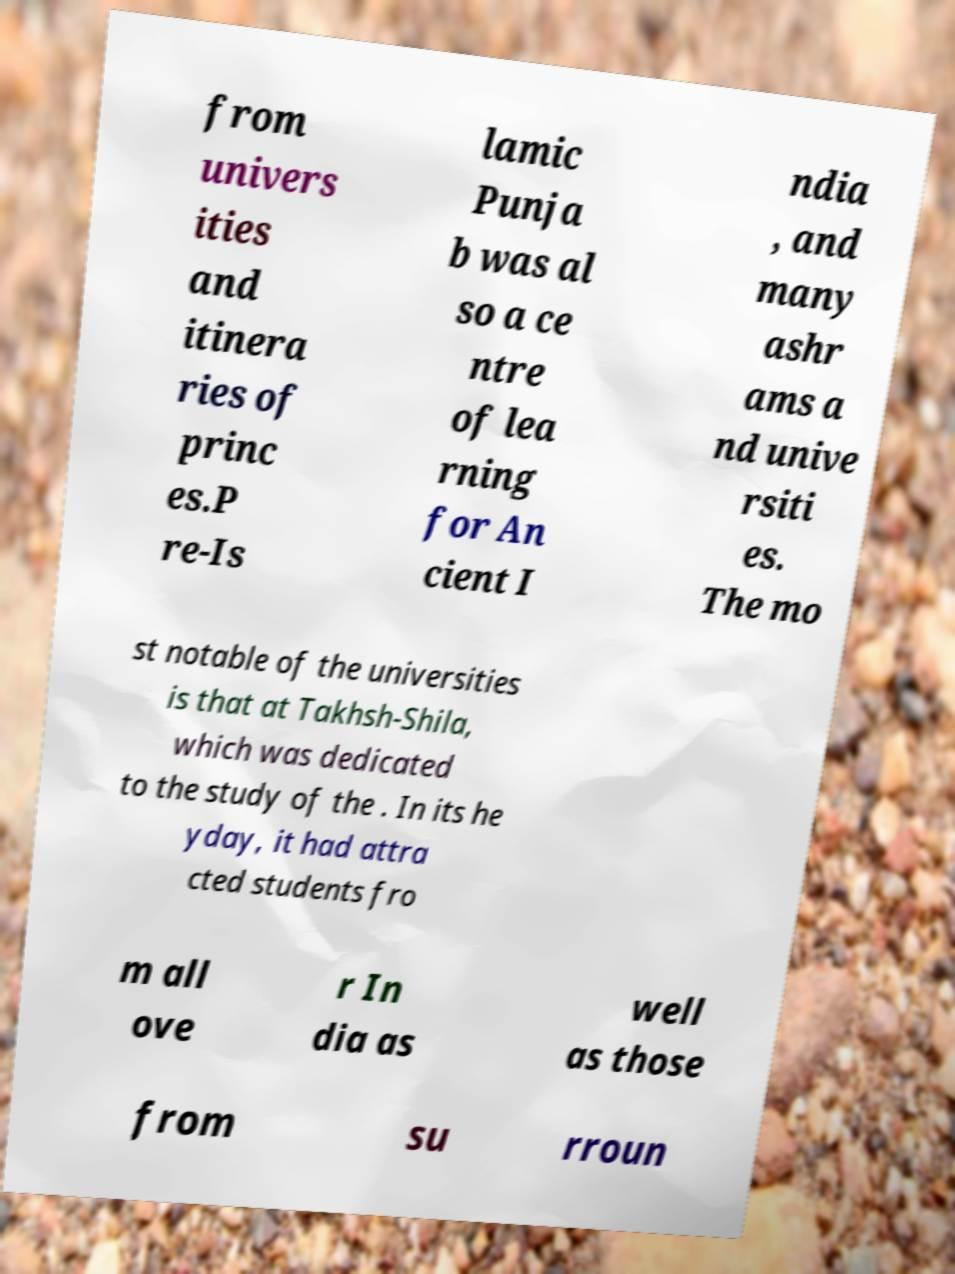Could you extract and type out the text from this image? from univers ities and itinera ries of princ es.P re-Is lamic Punja b was al so a ce ntre of lea rning for An cient I ndia , and many ashr ams a nd unive rsiti es. The mo st notable of the universities is that at Takhsh-Shila, which was dedicated to the study of the . In its he yday, it had attra cted students fro m all ove r In dia as well as those from su rroun 